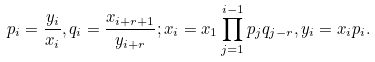<formula> <loc_0><loc_0><loc_500><loc_500>p _ { i } = \frac { y _ { i } } { x _ { i } } , q _ { i } = \frac { x _ { i + r + 1 } } { y _ { i + r } } ; x _ { i } = x _ { 1 } \prod _ { j = 1 } ^ { i - 1 } p _ { j } q _ { j - r } , y _ { i } = x _ { i } p _ { i } .</formula> 